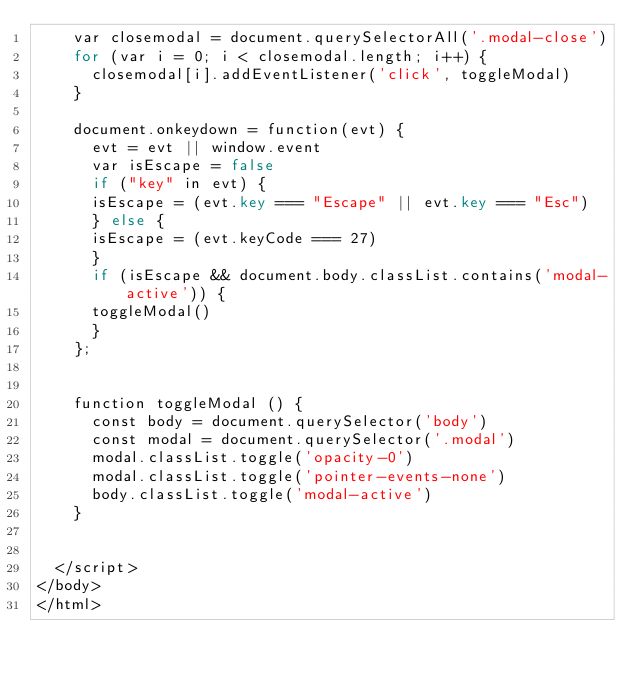<code> <loc_0><loc_0><loc_500><loc_500><_PHP_>    var closemodal = document.querySelectorAll('.modal-close')
    for (var i = 0; i < closemodal.length; i++) {
      closemodal[i].addEventListener('click', toggleModal)
    }

    document.onkeydown = function(evt) {
      evt = evt || window.event
      var isEscape = false
      if ("key" in evt) {
    	isEscape = (evt.key === "Escape" || evt.key === "Esc")
      } else {
    	isEscape = (evt.keyCode === 27)
      }
      if (isEscape && document.body.classList.contains('modal-active')) {
    	toggleModal()
      }
    };


    function toggleModal () {
      const body = document.querySelector('body')
      const modal = document.querySelector('.modal')
      modal.classList.toggle('opacity-0')
      modal.classList.toggle('pointer-events-none')
      body.classList.toggle('modal-active')
    }


  </script>
</body>
</html>
</code> 